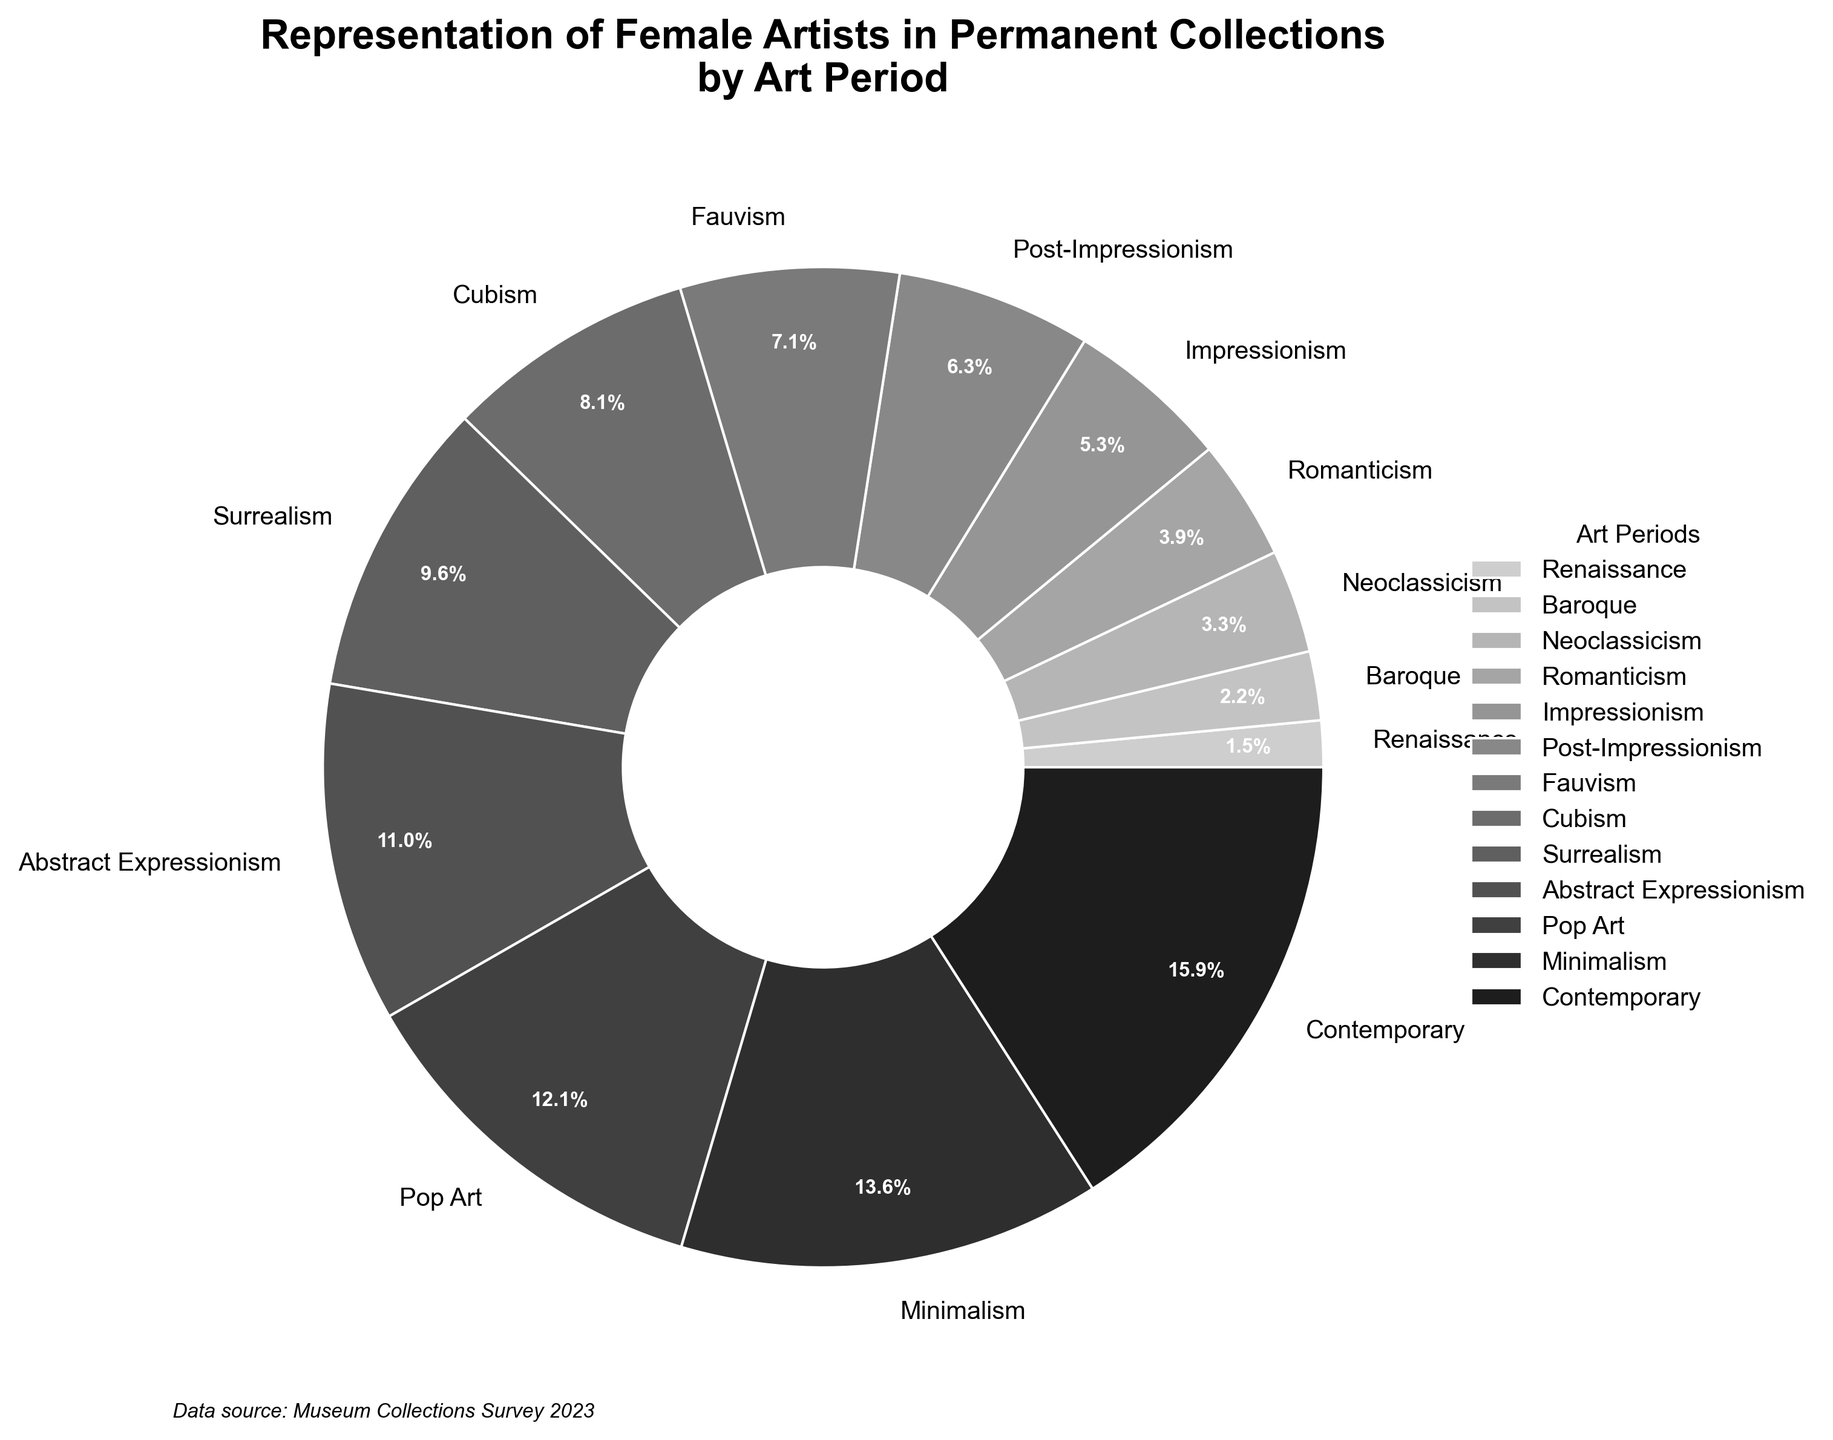What percentage of female artists are represented in the Contemporary art period? By looking at the pie chart, find the wedge labeled "Contemporary" and read the percentage displayed on it.
Answer: 37.2% Which art period has the least representation of female artists in permanent collections? Identify the smallest wedge by its size and corresponding label.
Answer: Renaissance How many art periods have a representation of female artists greater than 20%? Observe the wedges labeled with percentages and count how many are greater than 20%.
Answer: 4 Compare the representation of female artists in the Baroque and Neoclassicism periods. Which has a higher percentage? Find the wedges labeled "Baroque" and "Neoclassicism" and compare their percentages.
Answer: Neoclassicism What is the total percentage of female artists represented in art periods before the 20th century? Add percentages of Renaissance, Baroque, Neoclassicism, Romanticism, Impressionism, and Post-Impressionism.
Answer: 52.6% How does the representation of female artists in Fauvism compare to that in Cubism? Look at the percentages for Fauvism and Cubism and see which one is larger.
Answer: Cubism Which period shows nearly double the representation of female artists compared to Neoclassicism? Look for a period whose percentage is roughly double the Neoclassicism percentage (7.8%).
Answer: Surrealism Visualize the relative sizes in color: Which art period is represented by the darkest wedge? Look for the wedge colored darkest according to the grayscale color scheme.
Answer: Renaissance What is the difference in representation between Minimalism and Pop Art? Subtract the percentage of Pop Art from that of Minimalism.
Answer: 3.5% What is the average percentage representation of female artists across all listed art periods? Sum the percentages of all art periods and divide by the number of periods (13).
Answer: 17.4% 